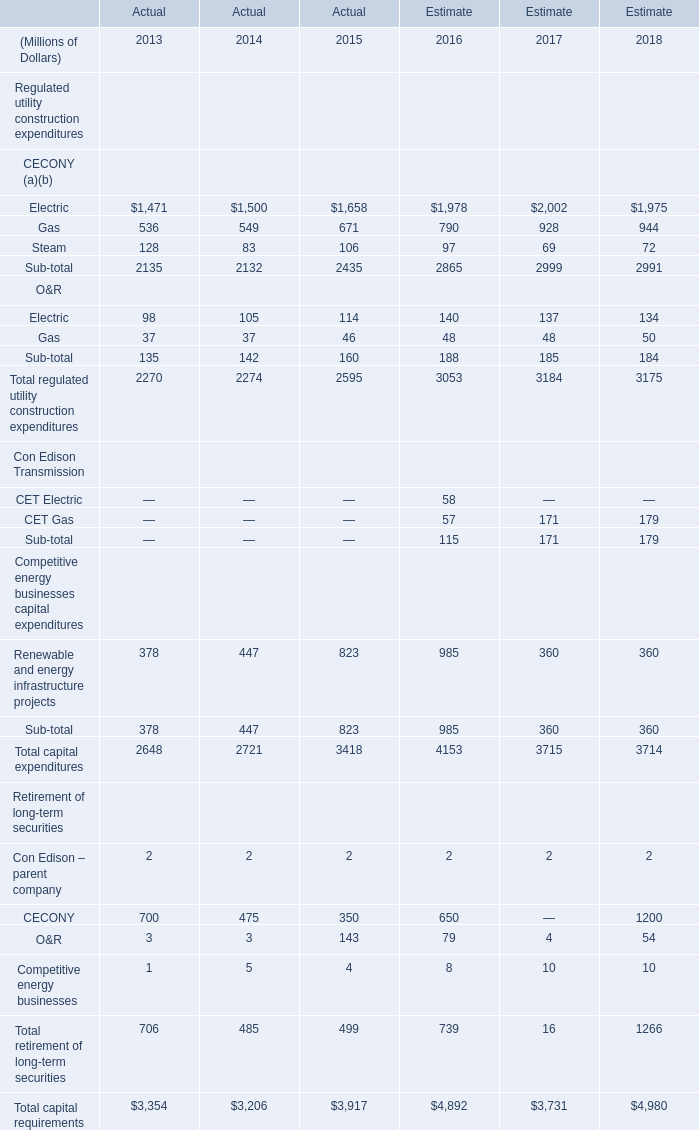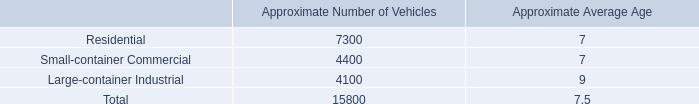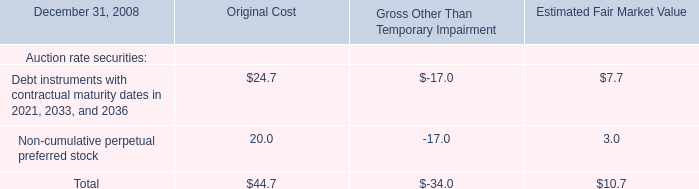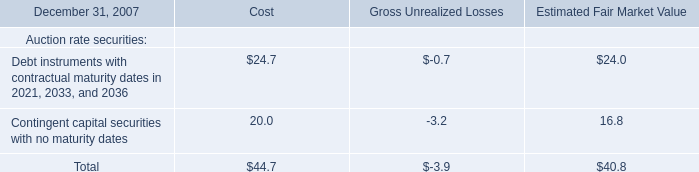What is the sum of Non-cumulative perpetual preferred stock of Original Cost in 2008 and Contingent capital securities with no maturity dates of Estimated Fair Market Value in 2007? 
Computations: (20.0 + 16.8)
Answer: 36.8. 